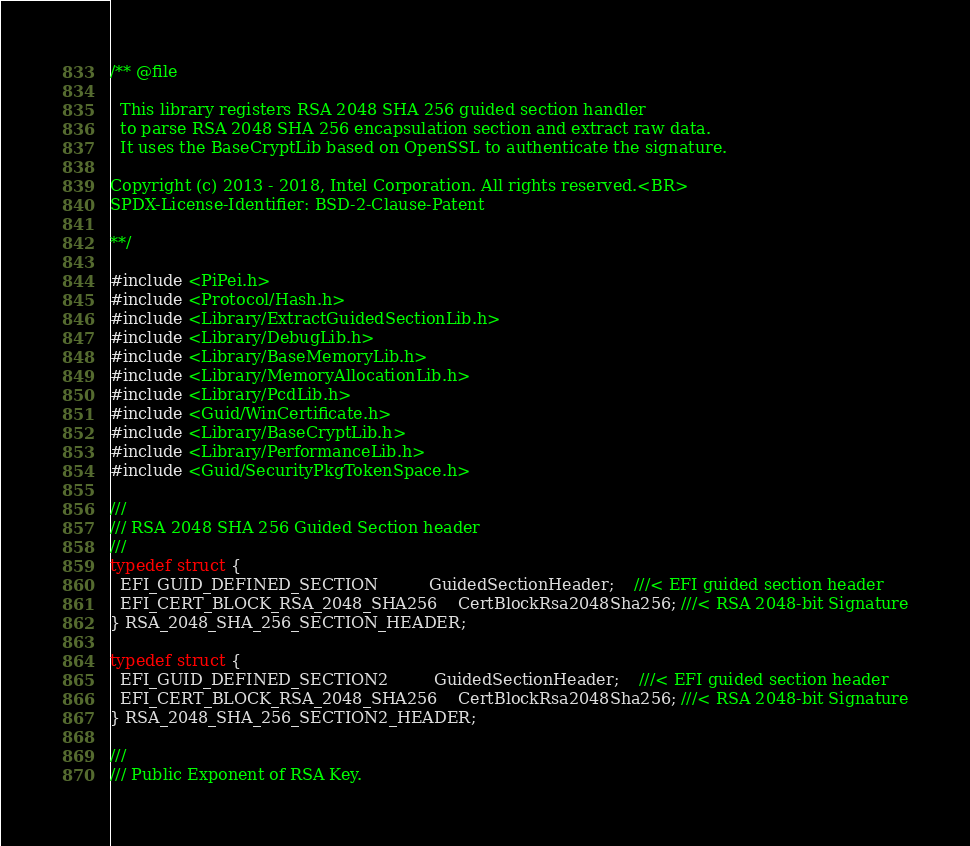Convert code to text. <code><loc_0><loc_0><loc_500><loc_500><_C_>/** @file

  This library registers RSA 2048 SHA 256 guided section handler
  to parse RSA 2048 SHA 256 encapsulation section and extract raw data.
  It uses the BaseCryptLib based on OpenSSL to authenticate the signature.

Copyright (c) 2013 - 2018, Intel Corporation. All rights reserved.<BR>
SPDX-License-Identifier: BSD-2-Clause-Patent

**/

#include <PiPei.h>
#include <Protocol/Hash.h>
#include <Library/ExtractGuidedSectionLib.h>
#include <Library/DebugLib.h>
#include <Library/BaseMemoryLib.h>
#include <Library/MemoryAllocationLib.h>
#include <Library/PcdLib.h>
#include <Guid/WinCertificate.h>
#include <Library/BaseCryptLib.h>
#include <Library/PerformanceLib.h>
#include <Guid/SecurityPkgTokenSpace.h>

///
/// RSA 2048 SHA 256 Guided Section header
///
typedef struct {
  EFI_GUID_DEFINED_SECTION          GuidedSectionHeader;    ///< EFI guided section header
  EFI_CERT_BLOCK_RSA_2048_SHA256    CertBlockRsa2048Sha256; ///< RSA 2048-bit Signature
} RSA_2048_SHA_256_SECTION_HEADER;

typedef struct {
  EFI_GUID_DEFINED_SECTION2         GuidedSectionHeader;    ///< EFI guided section header
  EFI_CERT_BLOCK_RSA_2048_SHA256    CertBlockRsa2048Sha256; ///< RSA 2048-bit Signature
} RSA_2048_SHA_256_SECTION2_HEADER;

///
/// Public Exponent of RSA Key.</code> 